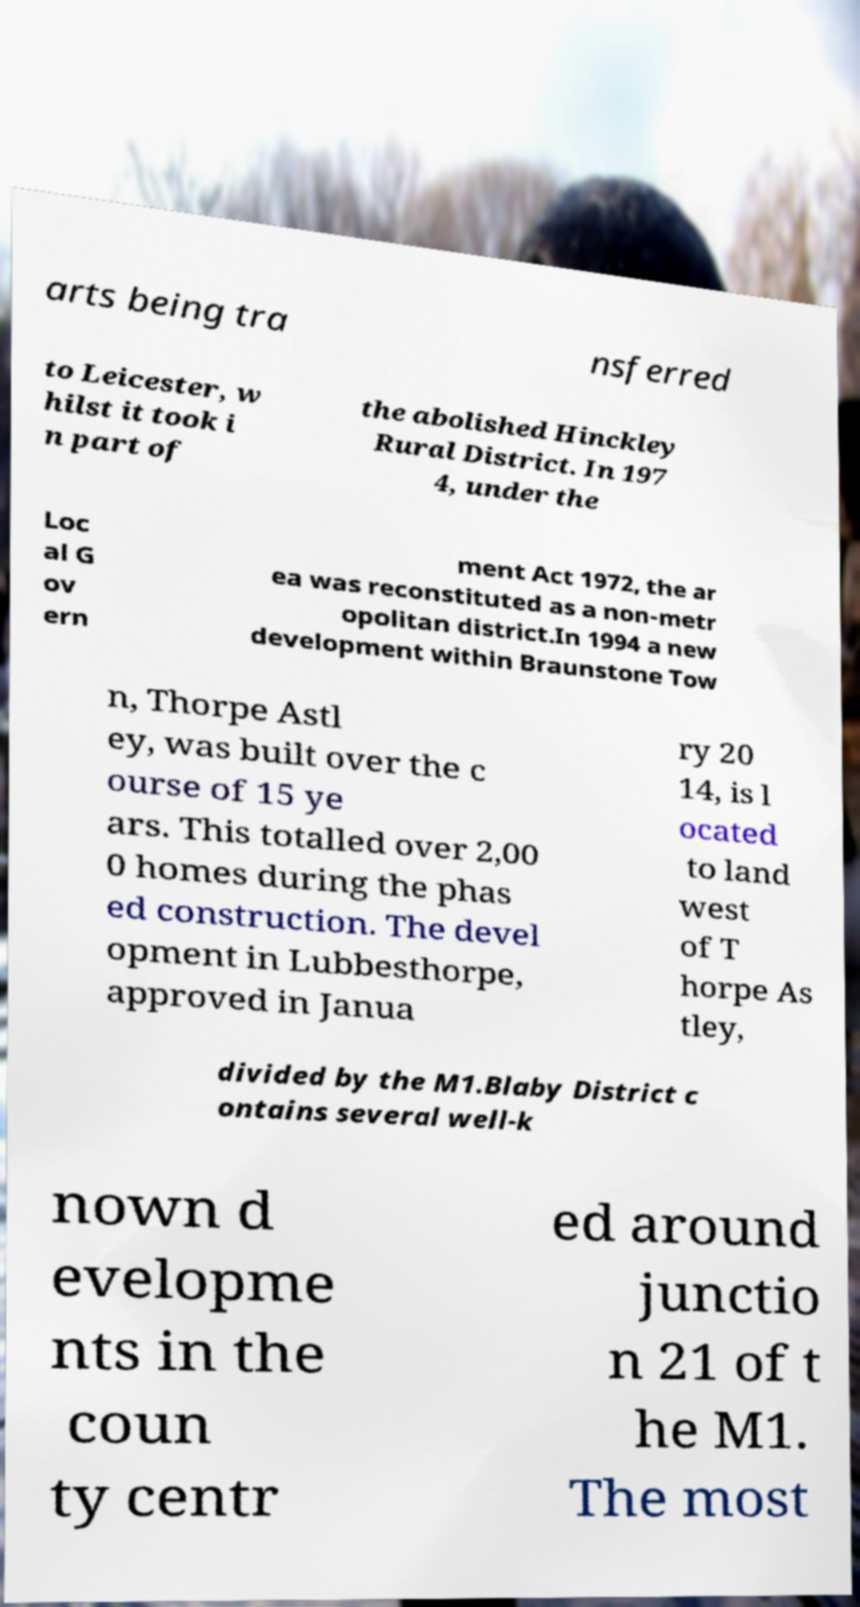Can you accurately transcribe the text from the provided image for me? arts being tra nsferred to Leicester, w hilst it took i n part of the abolished Hinckley Rural District. In 197 4, under the Loc al G ov ern ment Act 1972, the ar ea was reconstituted as a non-metr opolitan district.In 1994 a new development within Braunstone Tow n, Thorpe Astl ey, was built over the c ourse of 15 ye ars. This totalled over 2,00 0 homes during the phas ed construction. The devel opment in Lubbesthorpe, approved in Janua ry 20 14, is l ocated to land west of T horpe As tley, divided by the M1.Blaby District c ontains several well-k nown d evelopme nts in the coun ty centr ed around junctio n 21 of t he M1. The most 